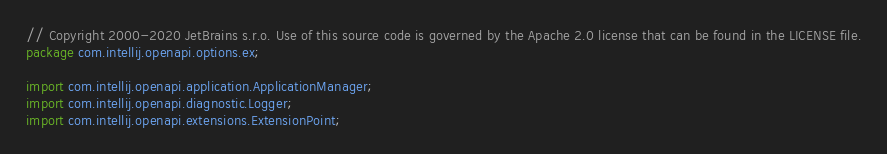<code> <loc_0><loc_0><loc_500><loc_500><_Java_>// Copyright 2000-2020 JetBrains s.r.o. Use of this source code is governed by the Apache 2.0 license that can be found in the LICENSE file.
package com.intellij.openapi.options.ex;

import com.intellij.openapi.application.ApplicationManager;
import com.intellij.openapi.diagnostic.Logger;
import com.intellij.openapi.extensions.ExtensionPoint;</code> 